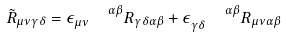Convert formula to latex. <formula><loc_0><loc_0><loc_500><loc_500>\tilde { R } _ { \mu \nu \gamma \delta } = \epsilon _ { \mu \nu } ^ { \quad \alpha \beta } R _ { \gamma \delta \alpha \beta } + \epsilon _ { \gamma \delta } ^ { \quad \alpha \beta } R _ { \mu \nu \alpha \beta }</formula> 